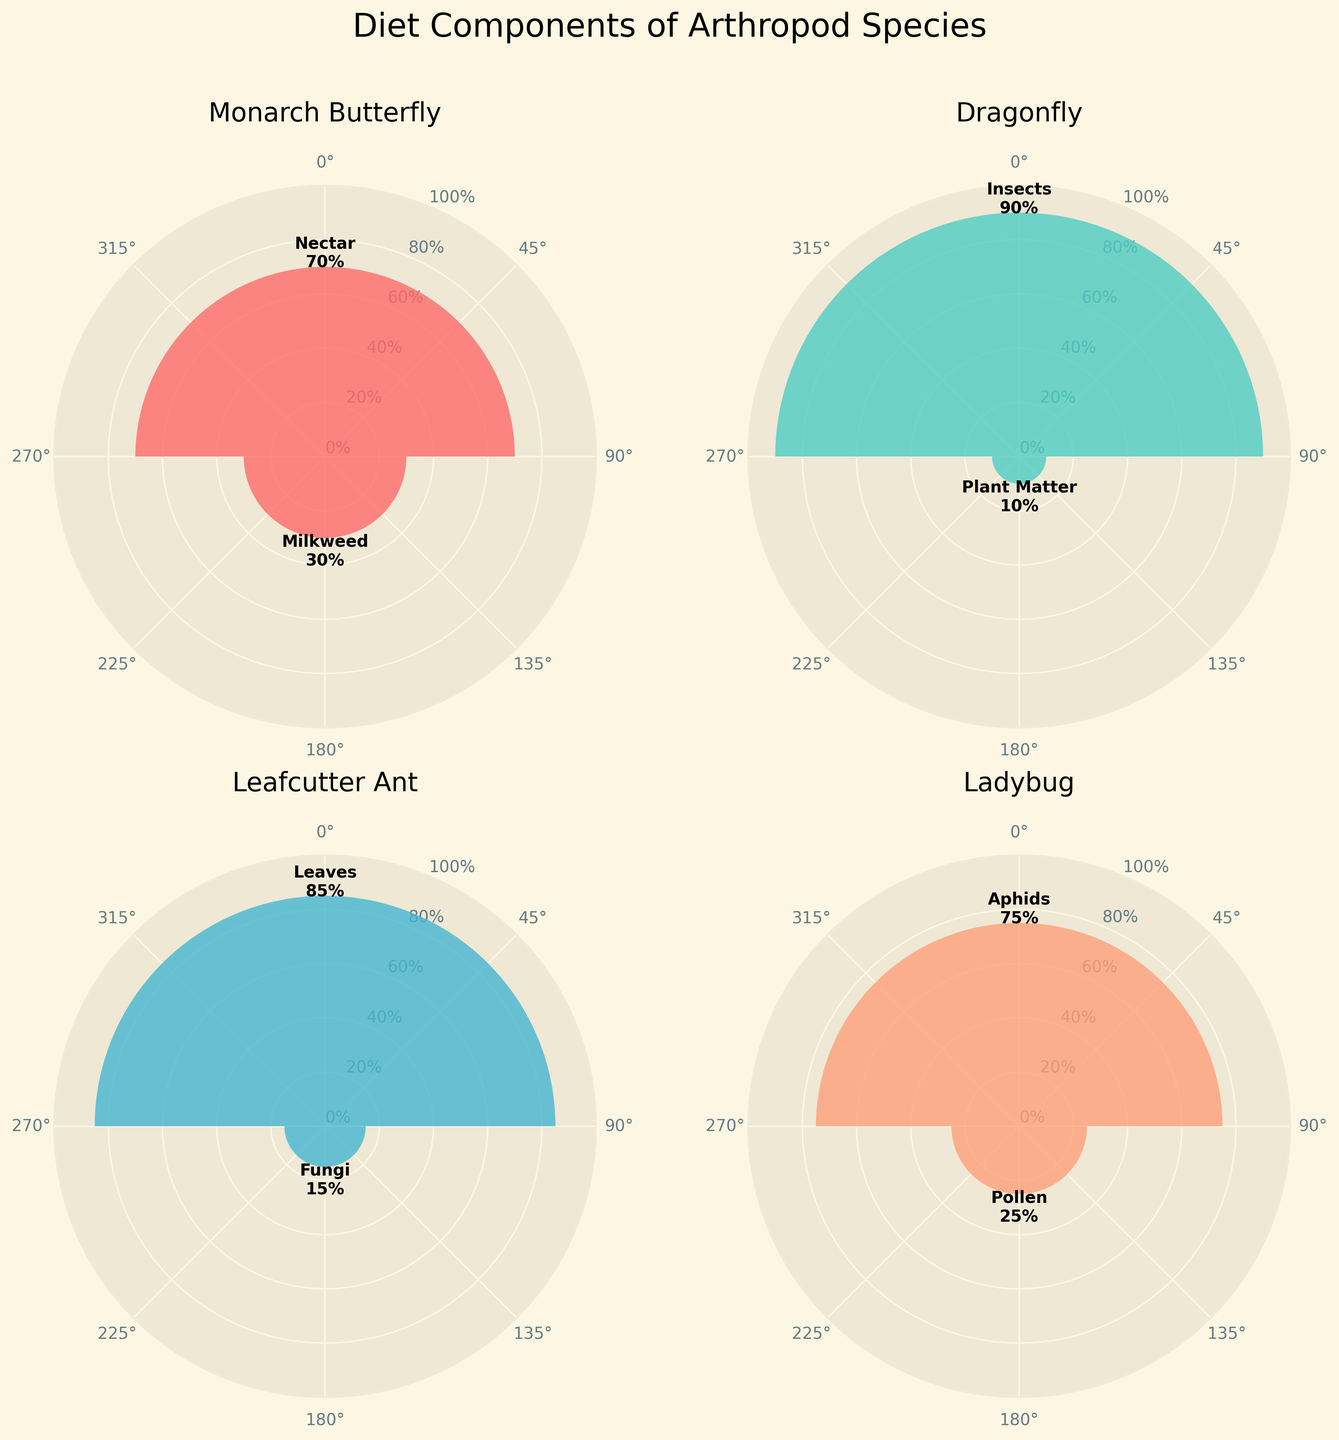What are the major diet components for the Monarch Butterfly? By looking at the chart for Monarch Butterfly, we can see the two labeled diet components: Nectar and Milkweed.
Answer: Nectar and Milkweed Which arthropod species has the highest proportion of a single diet component? Checking each chart, the Dragonfly has a diet component with 90%, which is the highest proportion for any single component.
Answer: Dragonfly For which species does "Plant Matter" make up part of their diet? We look at each species' chart and find that only the Dragonfly has a portion labeled as "Plant Matter".
Answer: Dragonfly How many diet components are there in total? Summing up all unique diet components for each species: Nectar, Milkweed, Insects, Plant Matter, Leaves, Fungi, Aphids, Pollen.
Answer: 8 Which species consumes insects as part of their diet? By examining the labels on each chart, only the Dragonfly is shown to consume "Insects".
Answer: Dragonfly Compare the proportions of "Milkweed" in Monarch Butterfly and "Fungi" in Leafcutter Ant. Which is higher? The Monarch Butterfly has 30% Milkweed and the Leafcutter Ant has 15% Fungi. 30% is higher than 15%.
Answer: Milkweed in Monarch Butterfly What is the proportion of "Leaves" in the Leafcutter Ant's diet? The chart for Leafcutter Ant shows that "Leaves" make up 85% of its diet.
Answer: 85% Which two species have diet components that add up to 100%? All species' charts add up to 100% as indicated: Monarch Butterfly (70% + 30%), Dragonfly (90% + 10%), Leafcutter Ant (85% + 15%), Ladybug (75% + 25%).
Answer: All species What portions of the charts have their labels appear further from the center? The Ladybug's "Aphids" and Dragonfly's "Insects" appear furthest from the center, indicating they have the highest proportions.
Answer: Aphids in Ladybug and Insects in Dragonfly Which diet component is exclusive to only one species and what species is it? Fungi is the only component exclusive to the Leafcutter Ant as seen in their chart.
Answer: Fungi in Leafcutter Ant 